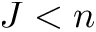<formula> <loc_0><loc_0><loc_500><loc_500>J < n</formula> 